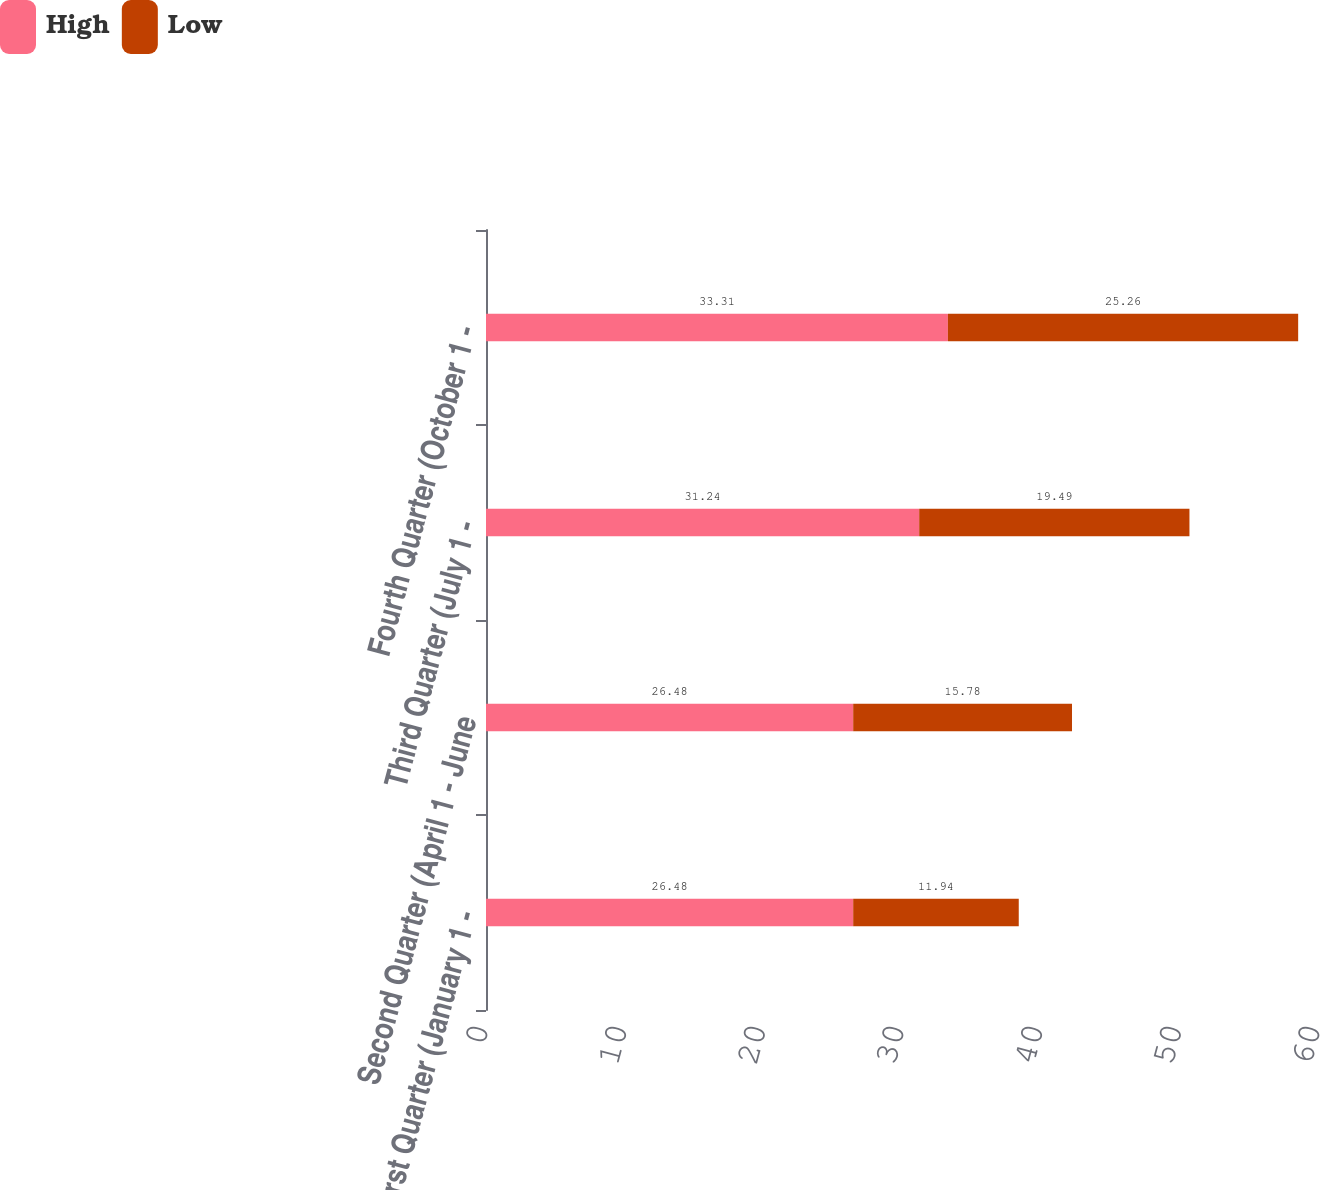Convert chart to OTSL. <chart><loc_0><loc_0><loc_500><loc_500><stacked_bar_chart><ecel><fcel>First Quarter (January 1 -<fcel>Second Quarter (April 1 - June<fcel>Third Quarter (July 1 -<fcel>Fourth Quarter (October 1 -<nl><fcel>High<fcel>26.48<fcel>26.48<fcel>31.24<fcel>33.31<nl><fcel>Low<fcel>11.94<fcel>15.78<fcel>19.49<fcel>25.26<nl></chart> 